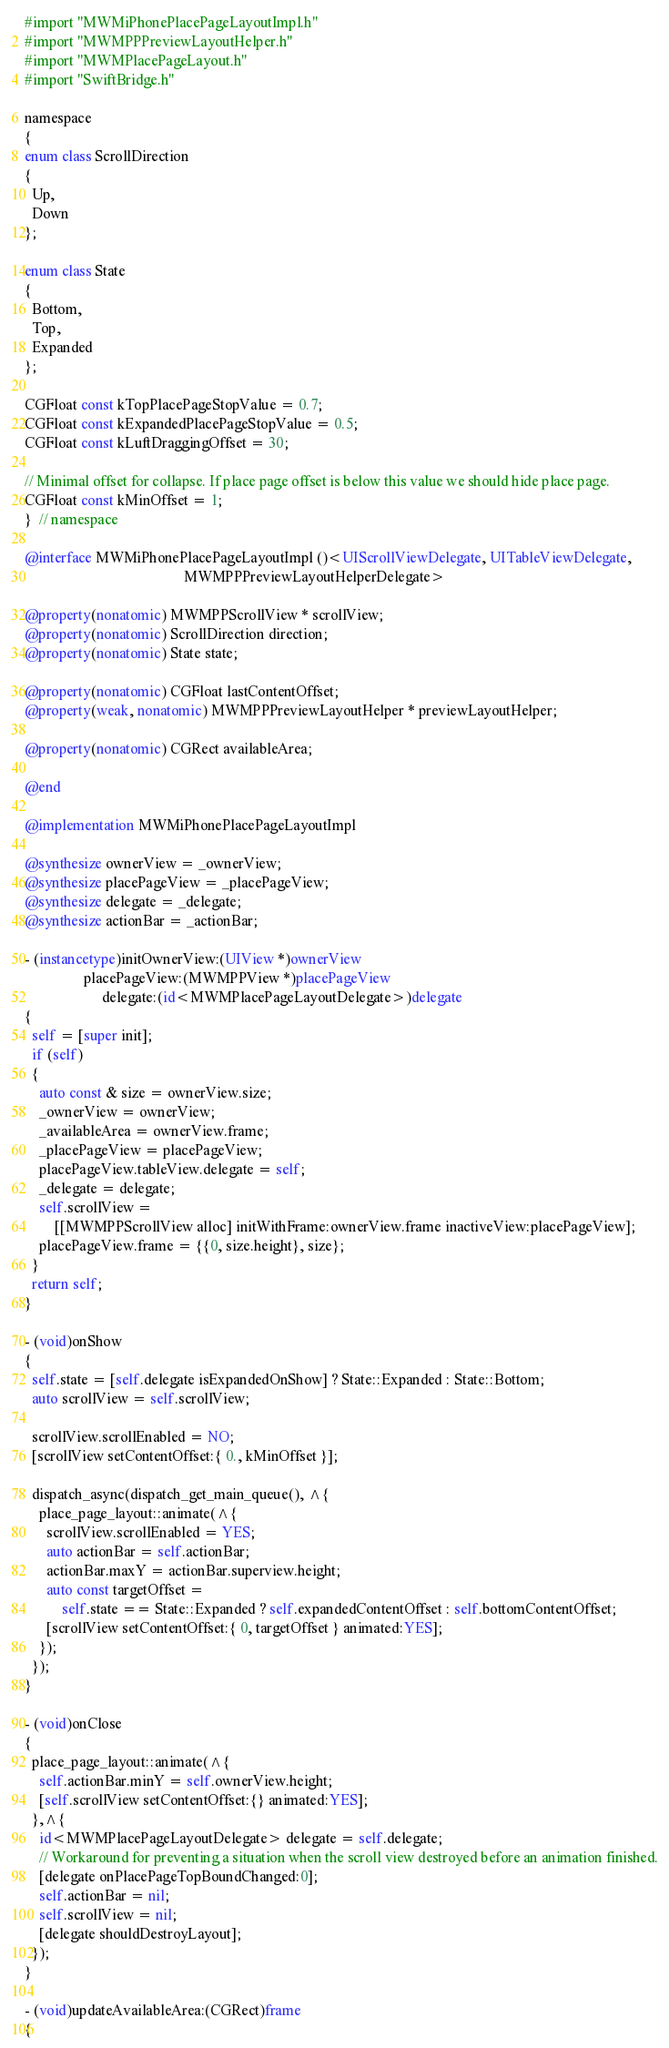<code> <loc_0><loc_0><loc_500><loc_500><_ObjectiveC_>#import "MWMiPhonePlacePageLayoutImpl.h"
#import "MWMPPPreviewLayoutHelper.h"
#import "MWMPlacePageLayout.h"
#import "SwiftBridge.h"

namespace
{
enum class ScrollDirection
{
  Up,
  Down
};

enum class State
{
  Bottom,
  Top,
  Expanded
};

CGFloat const kTopPlacePageStopValue = 0.7;
CGFloat const kExpandedPlacePageStopValue = 0.5;
CGFloat const kLuftDraggingOffset = 30;

// Minimal offset for collapse. If place page offset is below this value we should hide place page.
CGFloat const kMinOffset = 1;
}  // namespace

@interface MWMiPhonePlacePageLayoutImpl ()<UIScrollViewDelegate, UITableViewDelegate,
                                           MWMPPPreviewLayoutHelperDelegate>

@property(nonatomic) MWMPPScrollView * scrollView;
@property(nonatomic) ScrollDirection direction;
@property(nonatomic) State state;

@property(nonatomic) CGFloat lastContentOffset;
@property(weak, nonatomic) MWMPPPreviewLayoutHelper * previewLayoutHelper;

@property(nonatomic) CGRect availableArea;

@end

@implementation MWMiPhonePlacePageLayoutImpl

@synthesize ownerView = _ownerView;
@synthesize placePageView = _placePageView;
@synthesize delegate = _delegate;
@synthesize actionBar = _actionBar;

- (instancetype)initOwnerView:(UIView *)ownerView
                placePageView:(MWMPPView *)placePageView
                     delegate:(id<MWMPlacePageLayoutDelegate>)delegate
{
  self = [super init];
  if (self)
  {
    auto const & size = ownerView.size;
    _ownerView = ownerView;
    _availableArea = ownerView.frame;
    _placePageView = placePageView;
    placePageView.tableView.delegate = self;
    _delegate = delegate;
    self.scrollView =
        [[MWMPPScrollView alloc] initWithFrame:ownerView.frame inactiveView:placePageView];
    placePageView.frame = {{0, size.height}, size};
  }
  return self;
}

- (void)onShow
{
  self.state = [self.delegate isExpandedOnShow] ? State::Expanded : State::Bottom;
  auto scrollView = self.scrollView;
  
  scrollView.scrollEnabled = NO;
  [scrollView setContentOffset:{ 0., kMinOffset }];

  dispatch_async(dispatch_get_main_queue(), ^{
    place_page_layout::animate(^{
      scrollView.scrollEnabled = YES;
      auto actionBar = self.actionBar;
      actionBar.maxY = actionBar.superview.height;
      auto const targetOffset =
          self.state == State::Expanded ? self.expandedContentOffset : self.bottomContentOffset;
      [scrollView setContentOffset:{ 0, targetOffset } animated:YES];
    });
  });
}

- (void)onClose
{
  place_page_layout::animate(^{
    self.actionBar.minY = self.ownerView.height;
    [self.scrollView setContentOffset:{} animated:YES];
  },^{
    id<MWMPlacePageLayoutDelegate> delegate = self.delegate;
    // Workaround for preventing a situation when the scroll view destroyed before an animation finished.
    [delegate onPlacePageTopBoundChanged:0];
    self.actionBar = nil;
    self.scrollView = nil;
    [delegate shouldDestroyLayout];
  });
}

- (void)updateAvailableArea:(CGRect)frame
{</code> 